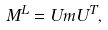<formula> <loc_0><loc_0><loc_500><loc_500>M ^ { L } = U m U ^ { T } ,</formula> 